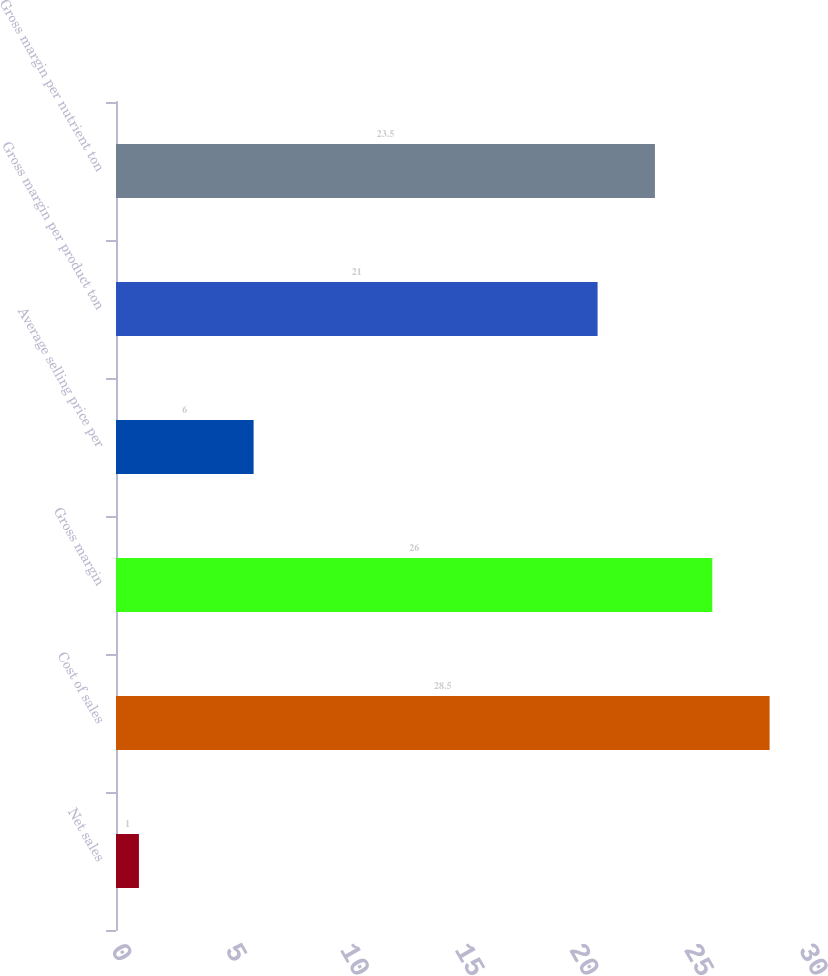<chart> <loc_0><loc_0><loc_500><loc_500><bar_chart><fcel>Net sales<fcel>Cost of sales<fcel>Gross margin<fcel>Average selling price per<fcel>Gross margin per product ton<fcel>Gross margin per nutrient ton<nl><fcel>1<fcel>28.5<fcel>26<fcel>6<fcel>21<fcel>23.5<nl></chart> 